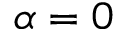<formula> <loc_0><loc_0><loc_500><loc_500>\alpha = 0</formula> 